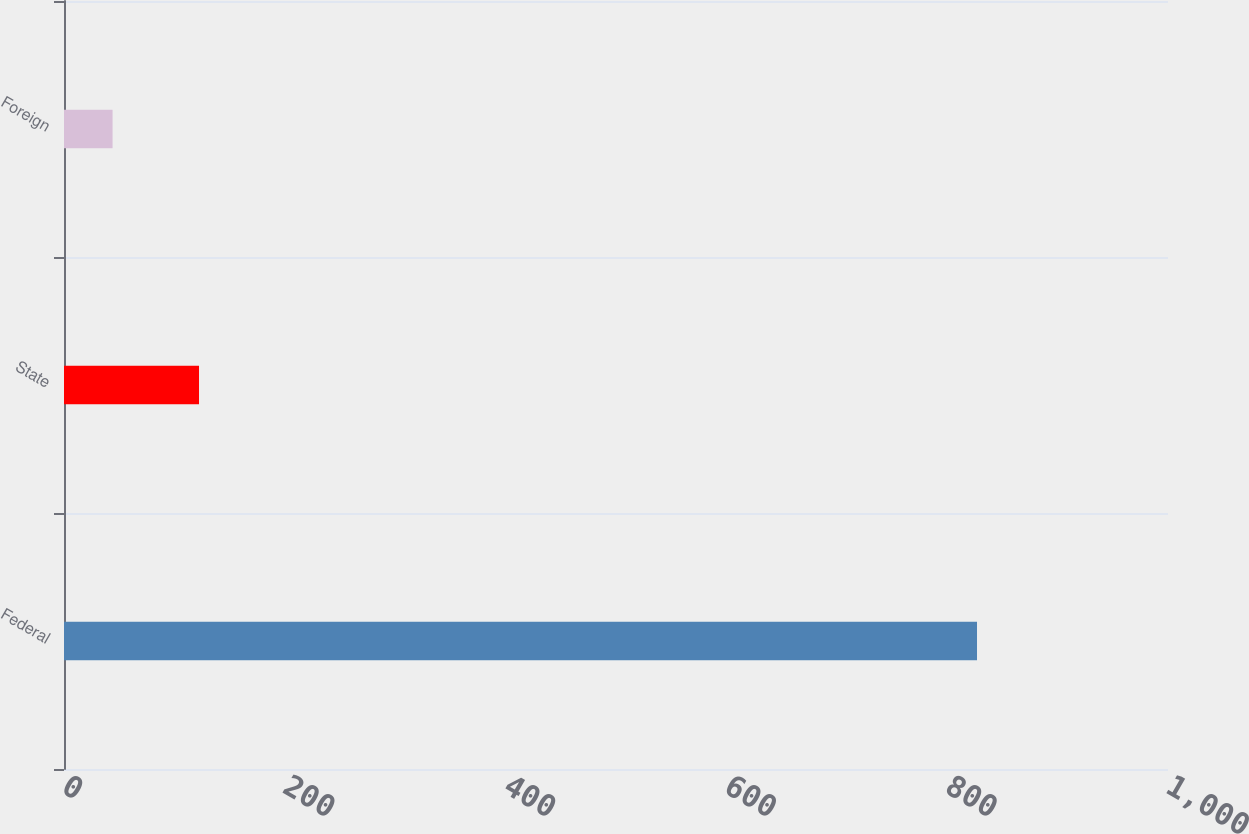<chart> <loc_0><loc_0><loc_500><loc_500><bar_chart><fcel>Federal<fcel>State<fcel>Foreign<nl><fcel>827<fcel>122.3<fcel>44<nl></chart> 